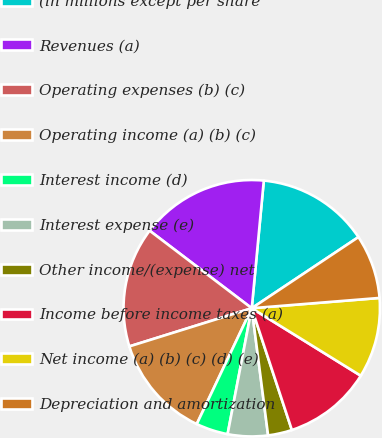<chart> <loc_0><loc_0><loc_500><loc_500><pie_chart><fcel>(in millions except per share<fcel>Revenues (a)<fcel>Operating expenses (b) (c)<fcel>Operating income (a) (b) (c)<fcel>Interest income (d)<fcel>Interest expense (e)<fcel>Other income/(expense) net<fcel>Income before income taxes (a)<fcel>Net income (a) (b) (c) (d) (e)<fcel>Depreciation and amortization<nl><fcel>14.14%<fcel>16.16%<fcel>15.15%<fcel>13.13%<fcel>4.04%<fcel>5.05%<fcel>3.03%<fcel>11.11%<fcel>10.1%<fcel>8.08%<nl></chart> 